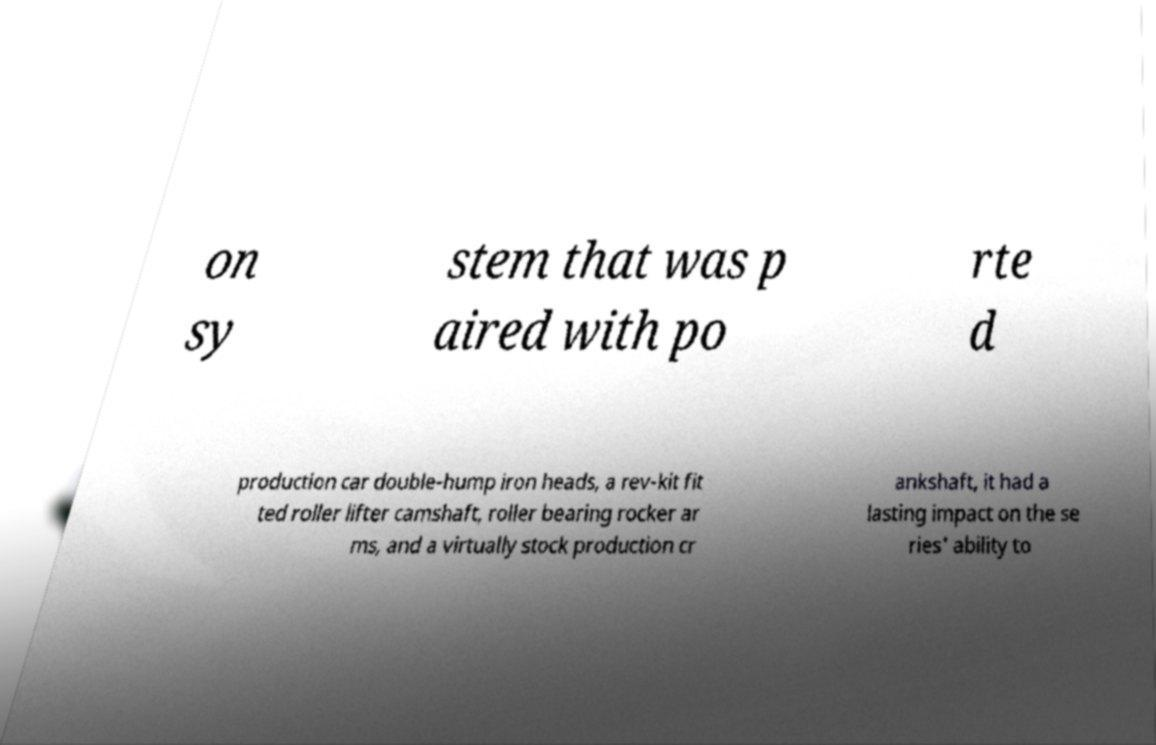Can you accurately transcribe the text from the provided image for me? on sy stem that was p aired with po rte d production car double-hump iron heads, a rev-kit fit ted roller lifter camshaft, roller bearing rocker ar ms, and a virtually stock production cr ankshaft, it had a lasting impact on the se ries' ability to 